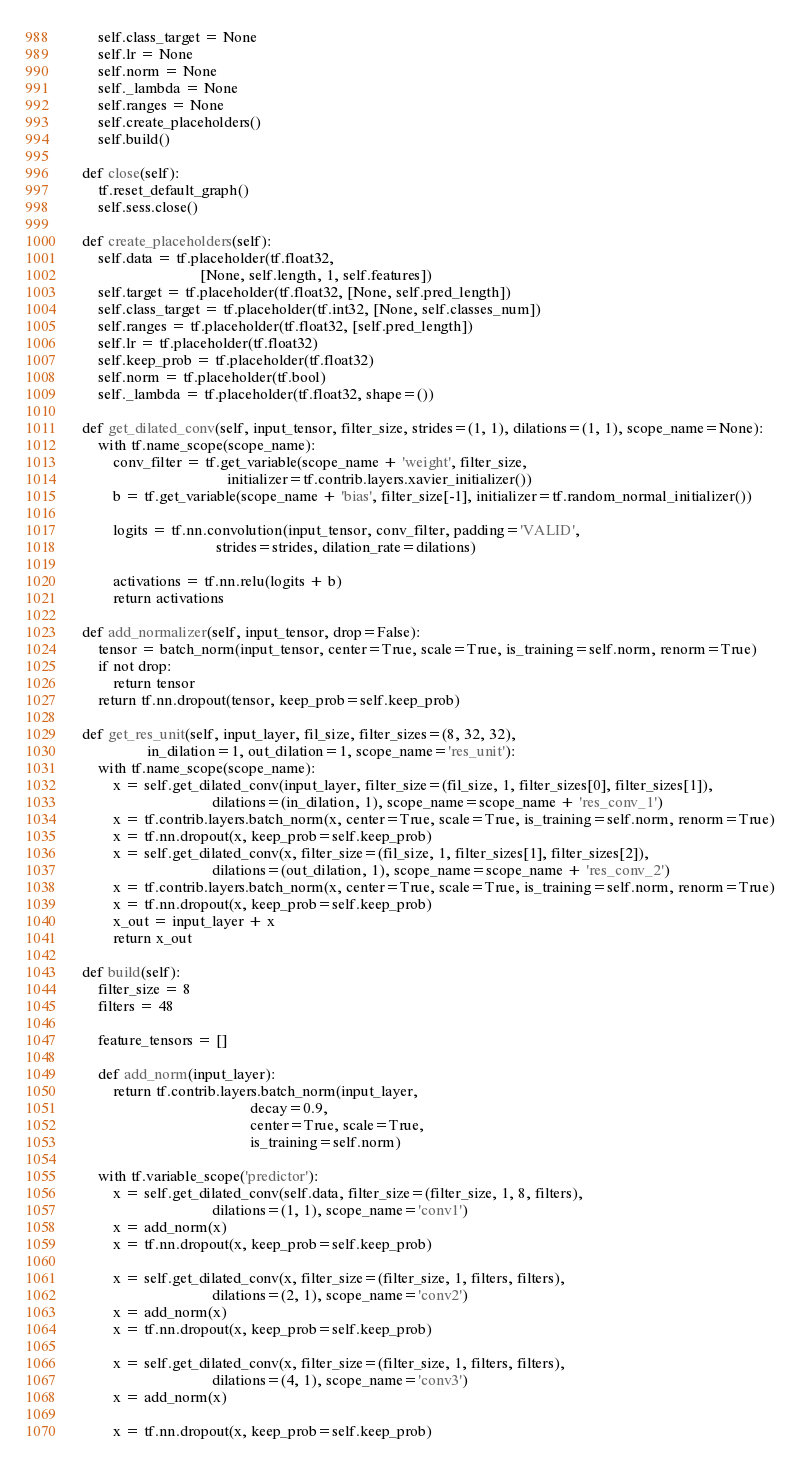Convert code to text. <code><loc_0><loc_0><loc_500><loc_500><_Python_>        self.class_target = None
        self.lr = None
        self.norm = None
        self._lambda = None
        self.ranges = None
        self.create_placeholders()
        self.build()

    def close(self):
        tf.reset_default_graph()
        self.sess.close()

    def create_placeholders(self):
        self.data = tf.placeholder(tf.float32,
                                   [None, self.length, 1, self.features])
        self.target = tf.placeholder(tf.float32, [None, self.pred_length])
        self.class_target = tf.placeholder(tf.int32, [None, self.classes_num])
        self.ranges = tf.placeholder(tf.float32, [self.pred_length])
        self.lr = tf.placeholder(tf.float32)
        self.keep_prob = tf.placeholder(tf.float32)
        self.norm = tf.placeholder(tf.bool)
        self._lambda = tf.placeholder(tf.float32, shape=())

    def get_dilated_conv(self, input_tensor, filter_size, strides=(1, 1), dilations=(1, 1), scope_name=None):
        with tf.name_scope(scope_name):
            conv_filter = tf.get_variable(scope_name + 'weight', filter_size,
                                          initializer=tf.contrib.layers.xavier_initializer())
            b = tf.get_variable(scope_name + 'bias', filter_size[-1], initializer=tf.random_normal_initializer())

            logits = tf.nn.convolution(input_tensor, conv_filter, padding='VALID',
                                       strides=strides, dilation_rate=dilations)

            activations = tf.nn.relu(logits + b)
            return activations

    def add_normalizer(self, input_tensor, drop=False):
        tensor = batch_norm(input_tensor, center=True, scale=True, is_training=self.norm, renorm=True)
        if not drop:
            return tensor
        return tf.nn.dropout(tensor, keep_prob=self.keep_prob)

    def get_res_unit(self, input_layer, fil_size, filter_sizes=(8, 32, 32),
                     in_dilation=1, out_dilation=1, scope_name='res_unit'):
        with tf.name_scope(scope_name):
            x = self.get_dilated_conv(input_layer, filter_size=(fil_size, 1, filter_sizes[0], filter_sizes[1]),
                                      dilations=(in_dilation, 1), scope_name=scope_name + 'res_conv_1')
            x = tf.contrib.layers.batch_norm(x, center=True, scale=True, is_training=self.norm, renorm=True)
            x = tf.nn.dropout(x, keep_prob=self.keep_prob)
            x = self.get_dilated_conv(x, filter_size=(fil_size, 1, filter_sizes[1], filter_sizes[2]),
                                      dilations=(out_dilation, 1), scope_name=scope_name + 'res_conv_2')
            x = tf.contrib.layers.batch_norm(x, center=True, scale=True, is_training=self.norm, renorm=True)
            x = tf.nn.dropout(x, keep_prob=self.keep_prob)
            x_out = input_layer + x
            return x_out

    def build(self):
        filter_size = 8
        filters = 48

        feature_tensors = []

        def add_norm(input_layer):
            return tf.contrib.layers.batch_norm(input_layer,
                                                decay=0.9,
                                                center=True, scale=True,
                                                is_training=self.norm)

        with tf.variable_scope('predictor'):
            x = self.get_dilated_conv(self.data, filter_size=(filter_size, 1, 8, filters),
                                      dilations=(1, 1), scope_name='conv1')
            x = add_norm(x)
            x = tf.nn.dropout(x, keep_prob=self.keep_prob)

            x = self.get_dilated_conv(x, filter_size=(filter_size, 1, filters, filters),
                                      dilations=(2, 1), scope_name='conv2')
            x = add_norm(x)
            x = tf.nn.dropout(x, keep_prob=self.keep_prob)

            x = self.get_dilated_conv(x, filter_size=(filter_size, 1, filters, filters),
                                      dilations=(4, 1), scope_name='conv3')
            x = add_norm(x)

            x = tf.nn.dropout(x, keep_prob=self.keep_prob)
</code> 